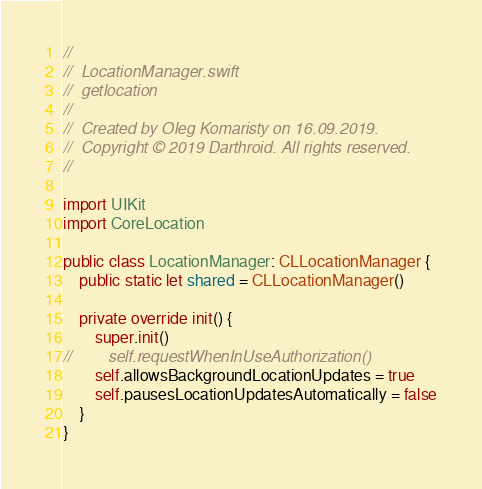<code> <loc_0><loc_0><loc_500><loc_500><_Swift_>//
//  LocationManager.swift
//  getlocation
//
//  Created by Oleg Komaristy on 16.09.2019.
//  Copyright © 2019 Darthroid. All rights reserved.
//

import UIKit
import CoreLocation

public class LocationManager: CLLocationManager {
    public static let shared = CLLocationManager()

    private override init() {
		super.init()
//        self.requestWhenInUseAuthorization()
        self.allowsBackgroundLocationUpdates = true
        self.pausesLocationUpdatesAutomatically = false
    }
}
</code> 